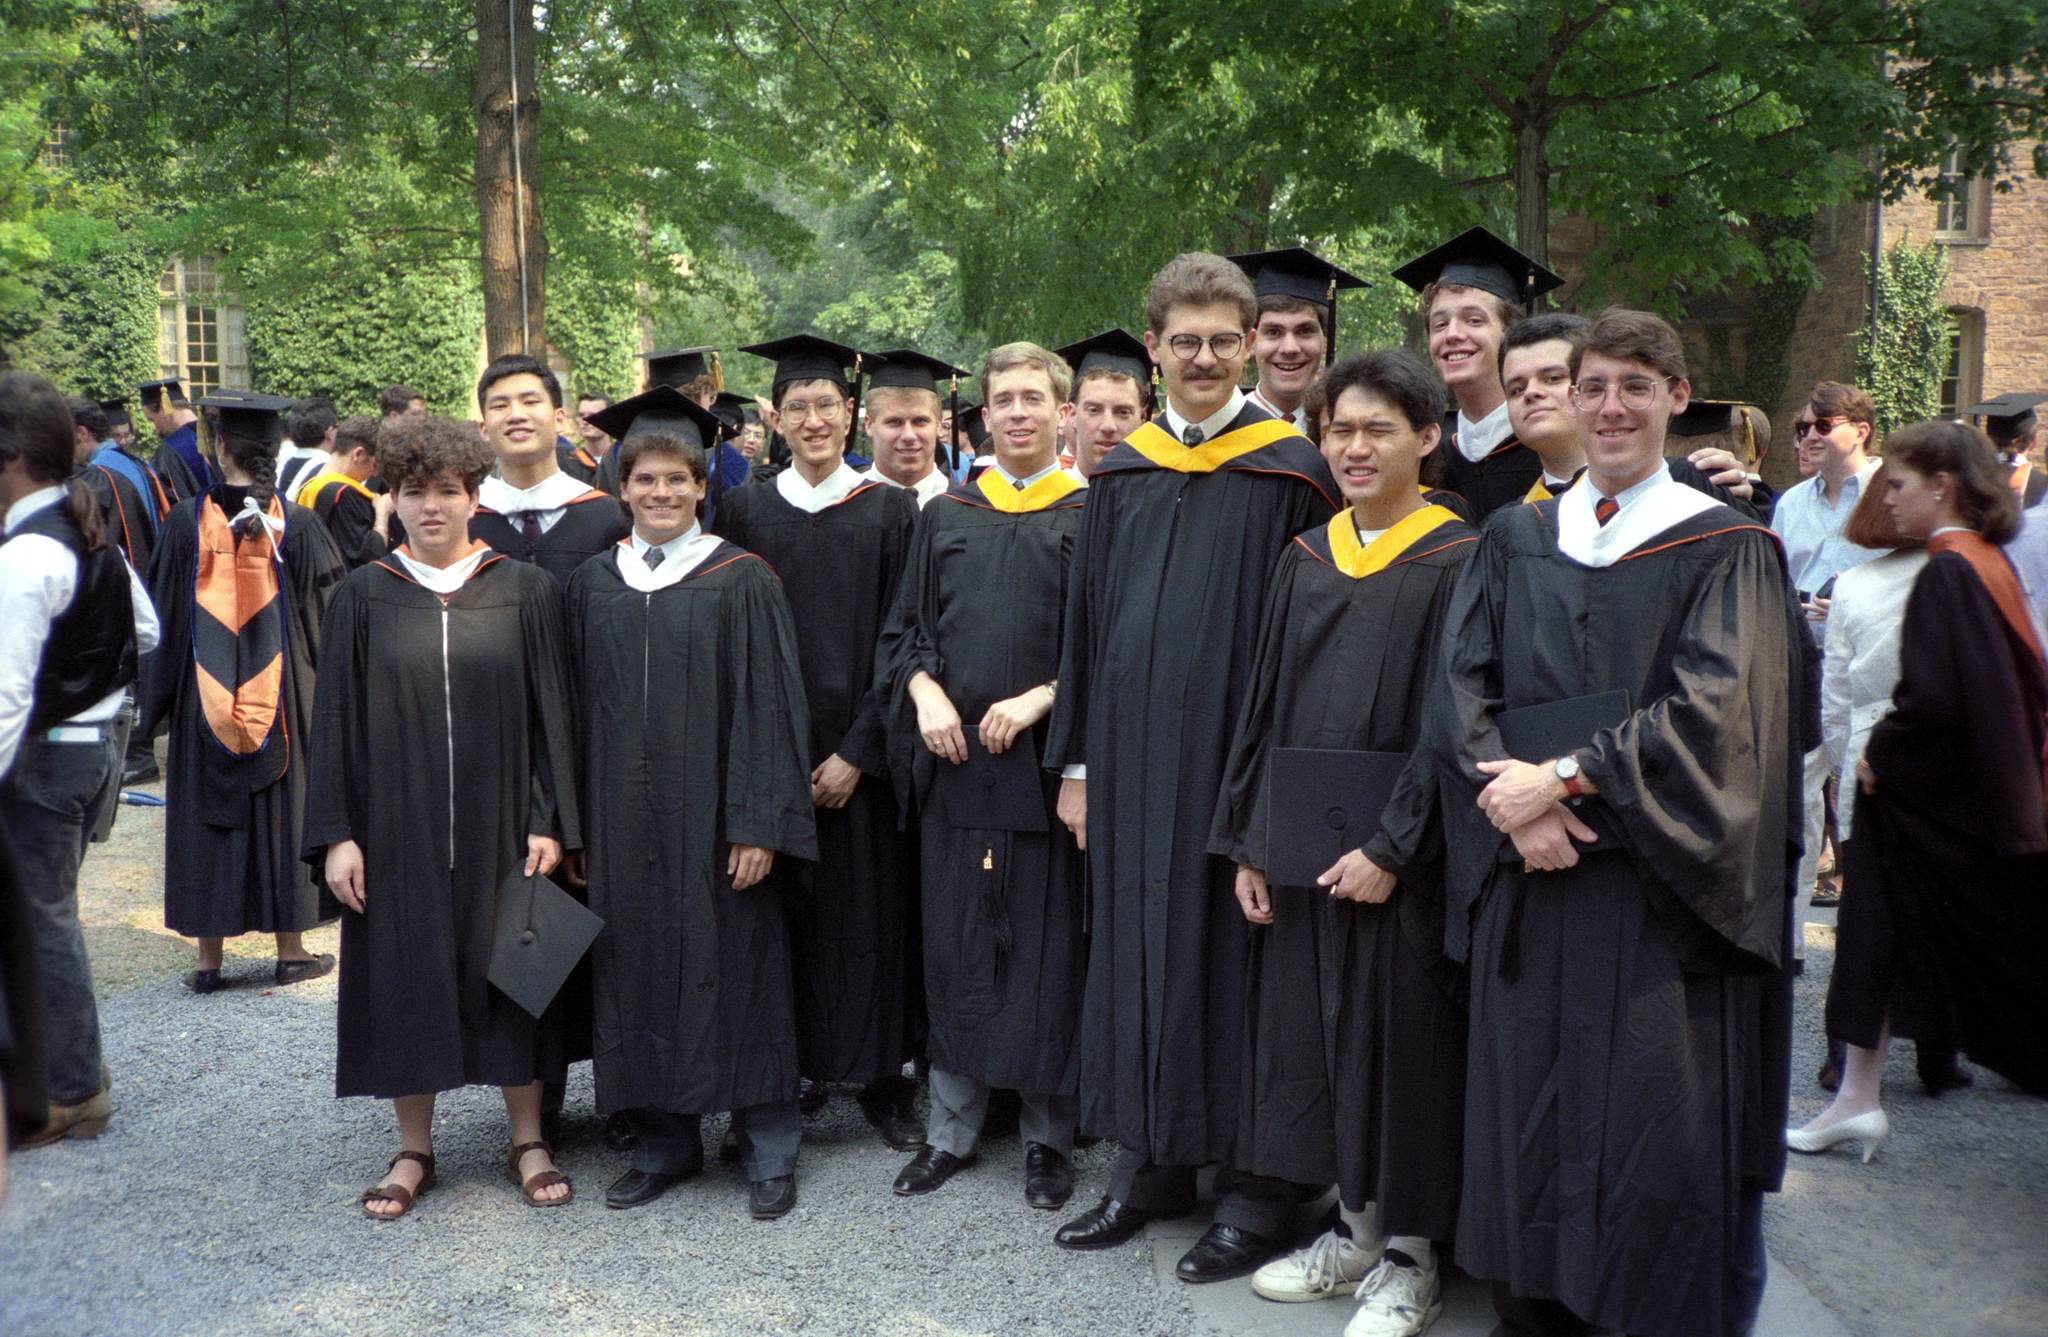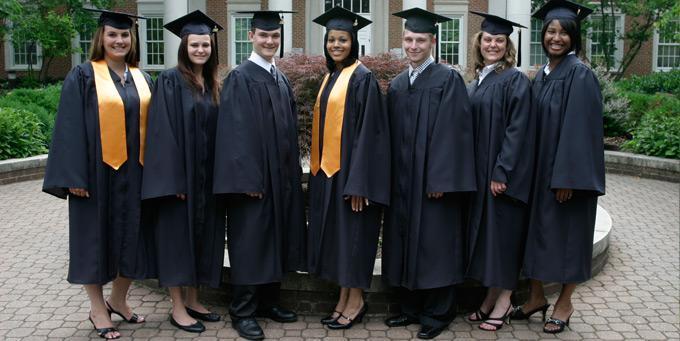The first image is the image on the left, the second image is the image on the right. Analyze the images presented: Is the assertion "An image includes multiple graduates in wine-colored gowns." valid? Answer yes or no. No. The first image is the image on the left, the second image is the image on the right. For the images displayed, is the sentence "All graduates in each image are wearing identical gowns and sashes." factually correct? Answer yes or no. No. The first image is the image on the left, the second image is the image on the right. Assess this claim about the two images: "In one image, at least three graduates are wearing red gowns and caps, while a second image shows at least four graduates in black gowns with gold sashes.". Correct or not? Answer yes or no. No. The first image is the image on the left, the second image is the image on the right. For the images shown, is this caption "At least three camera-facing graduates in burgundy robes are in one image." true? Answer yes or no. No. 